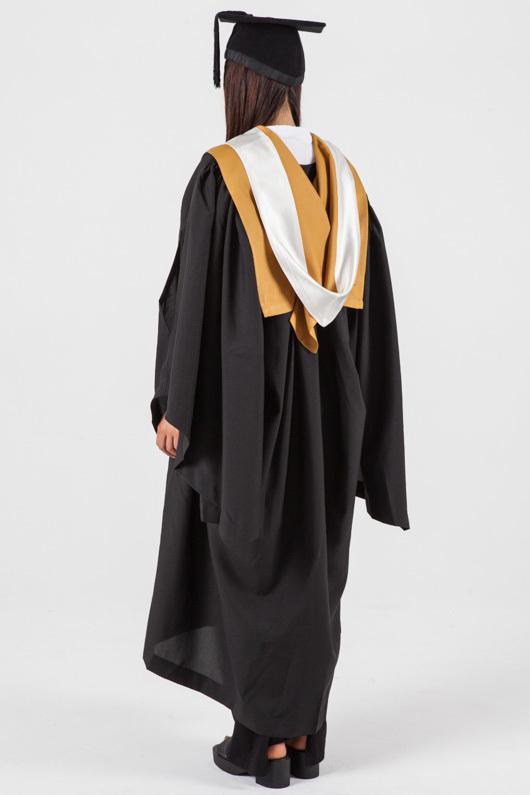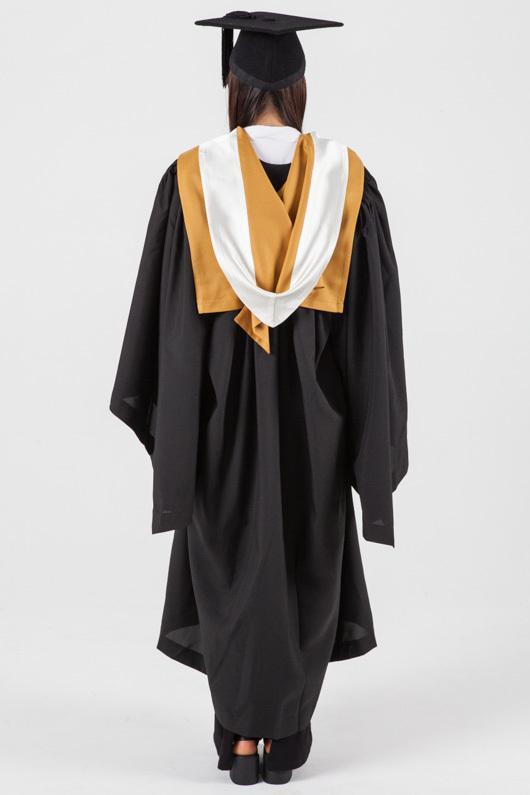The first image is the image on the left, the second image is the image on the right. Examine the images to the left and right. Is the description "There are two women in graduation clothes facing the camera." accurate? Answer yes or no. No. The first image is the image on the left, the second image is the image on the right. Given the left and right images, does the statement "women facing forward in a cap and gown" hold true? Answer yes or no. No. 